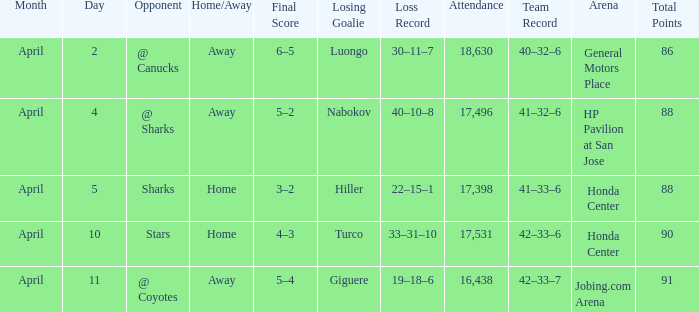Which Loss has a Record of 41–32–6? Nabokov (40–10–8). 